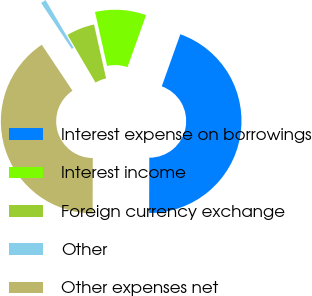Convert chart. <chart><loc_0><loc_0><loc_500><loc_500><pie_chart><fcel>Interest expense on borrowings<fcel>Interest income<fcel>Foreign currency exchange<fcel>Other<fcel>Other expenses net<nl><fcel>44.6%<fcel>8.96%<fcel>4.94%<fcel>0.92%<fcel>40.58%<nl></chart> 